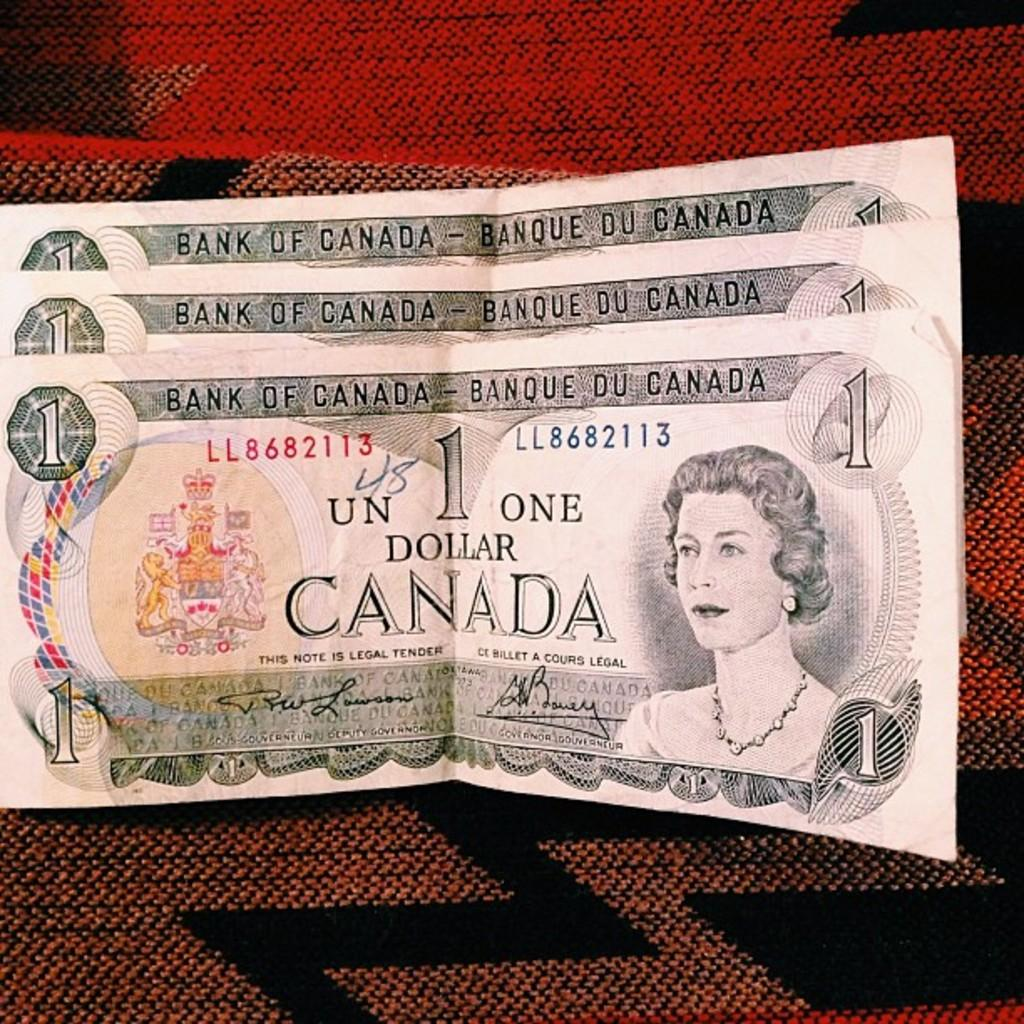What type of currency is visible in the image? There are one dollar currency notes in the image. Where are the currency notes located in the image? The currency notes are in the center of the image. Are there any jellyfish swimming in the image? No, there are no jellyfish present in the image. 